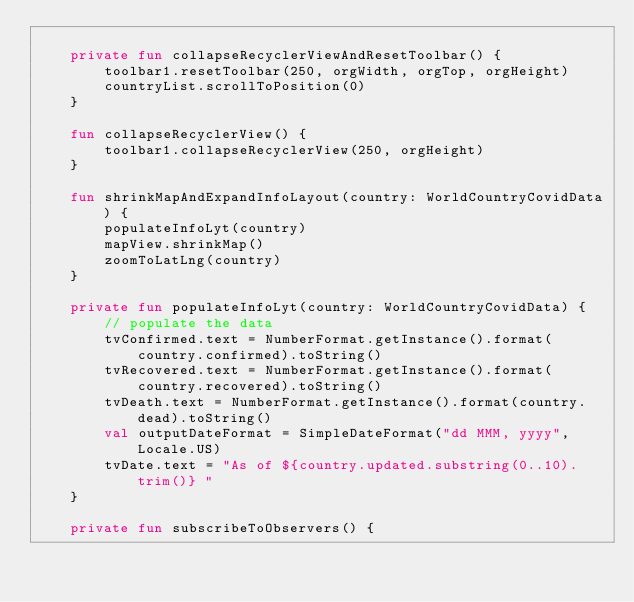<code> <loc_0><loc_0><loc_500><loc_500><_Kotlin_>
    private fun collapseRecyclerViewAndResetToolbar() {
        toolbar1.resetToolbar(250, orgWidth, orgTop, orgHeight)
        countryList.scrollToPosition(0)
    }

    fun collapseRecyclerView() {
        toolbar1.collapseRecyclerView(250, orgHeight)
    }

    fun shrinkMapAndExpandInfoLayout(country: WorldCountryCovidData) {
        populateInfoLyt(country)
        mapView.shrinkMap()
        zoomToLatLng(country)
    }

    private fun populateInfoLyt(country: WorldCountryCovidData) {
        // populate the data
        tvConfirmed.text = NumberFormat.getInstance().format(country.confirmed).toString()
        tvRecovered.text = NumberFormat.getInstance().format(country.recovered).toString()
        tvDeath.text = NumberFormat.getInstance().format(country.dead).toString()
        val outputDateFormat = SimpleDateFormat("dd MMM, yyyy", Locale.US)
        tvDate.text = "As of ${country.updated.substring(0..10).trim()} "
    }

    private fun subscribeToObservers() {
</code> 